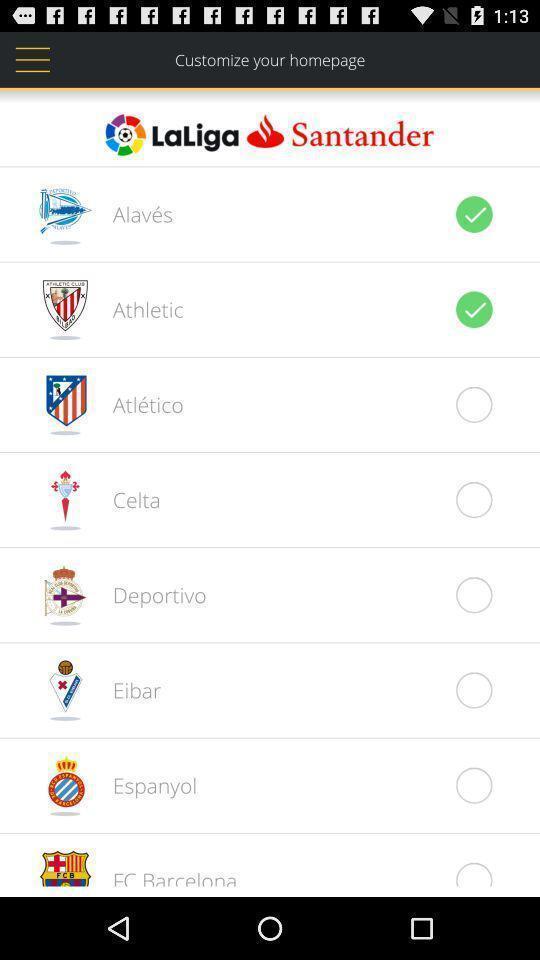Provide a textual representation of this image. Screen asking to customize the home page. 